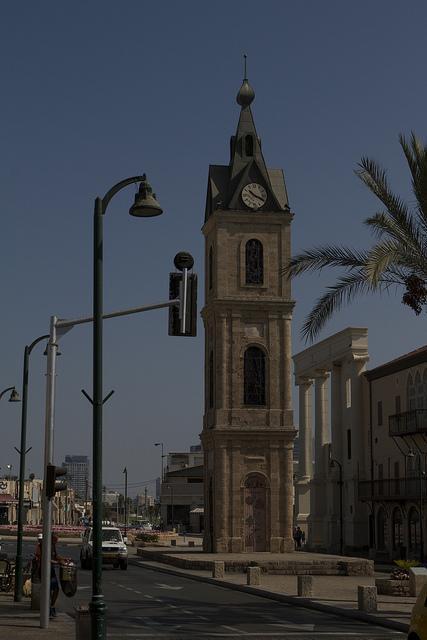How many clock faces are there?
Give a very brief answer. 1. How many stories are in the center building?
Give a very brief answer. 3. How many black and white poles are there?
Give a very brief answer. 0. How many newspaper vending machines are there?
Give a very brief answer. 0. How many types of automobiles are in the photo?
Give a very brief answer. 1. How many lights can be seen?
Give a very brief answer. 2. How many clocks are visible?
Give a very brief answer. 1. How many hands does the clock have?
Give a very brief answer. 2. How many clock faces are shown?
Give a very brief answer. 1. How many palm trees do you see?
Give a very brief answer. 1. How many sides does the clock tower have?
Give a very brief answer. 4. How many clocks are in the picture?
Give a very brief answer. 1. How many elephants are laying down?
Give a very brief answer. 0. 